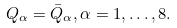<formula> <loc_0><loc_0><loc_500><loc_500>Q _ { \alpha } = \bar { Q } _ { \alpha } , \alpha = 1 , \dots , 8 .</formula> 